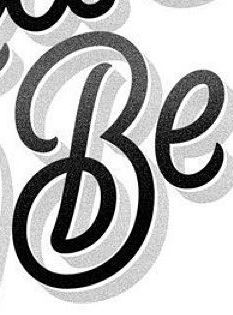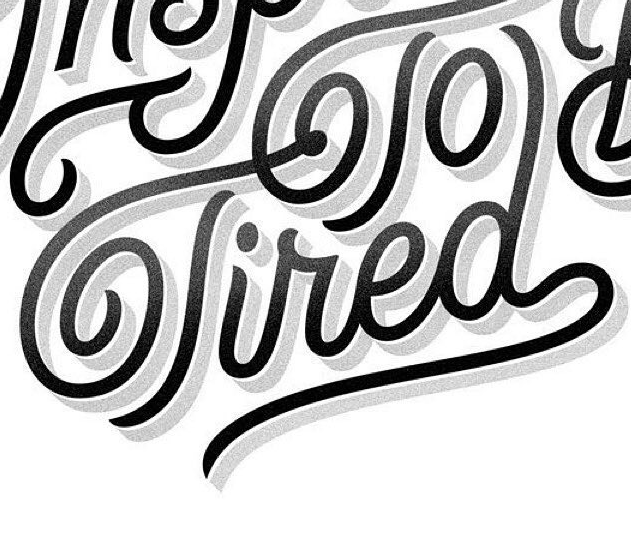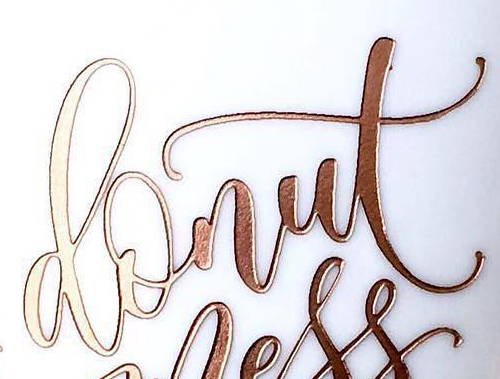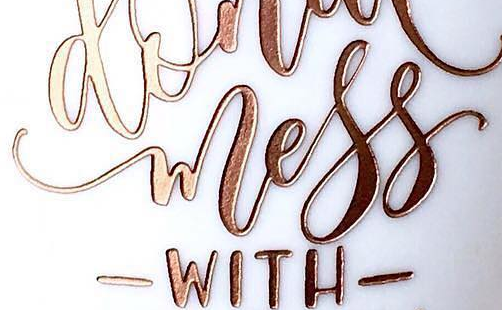What text is displayed in these images sequentially, separated by a semicolon? Be; Tired; donut; wless 